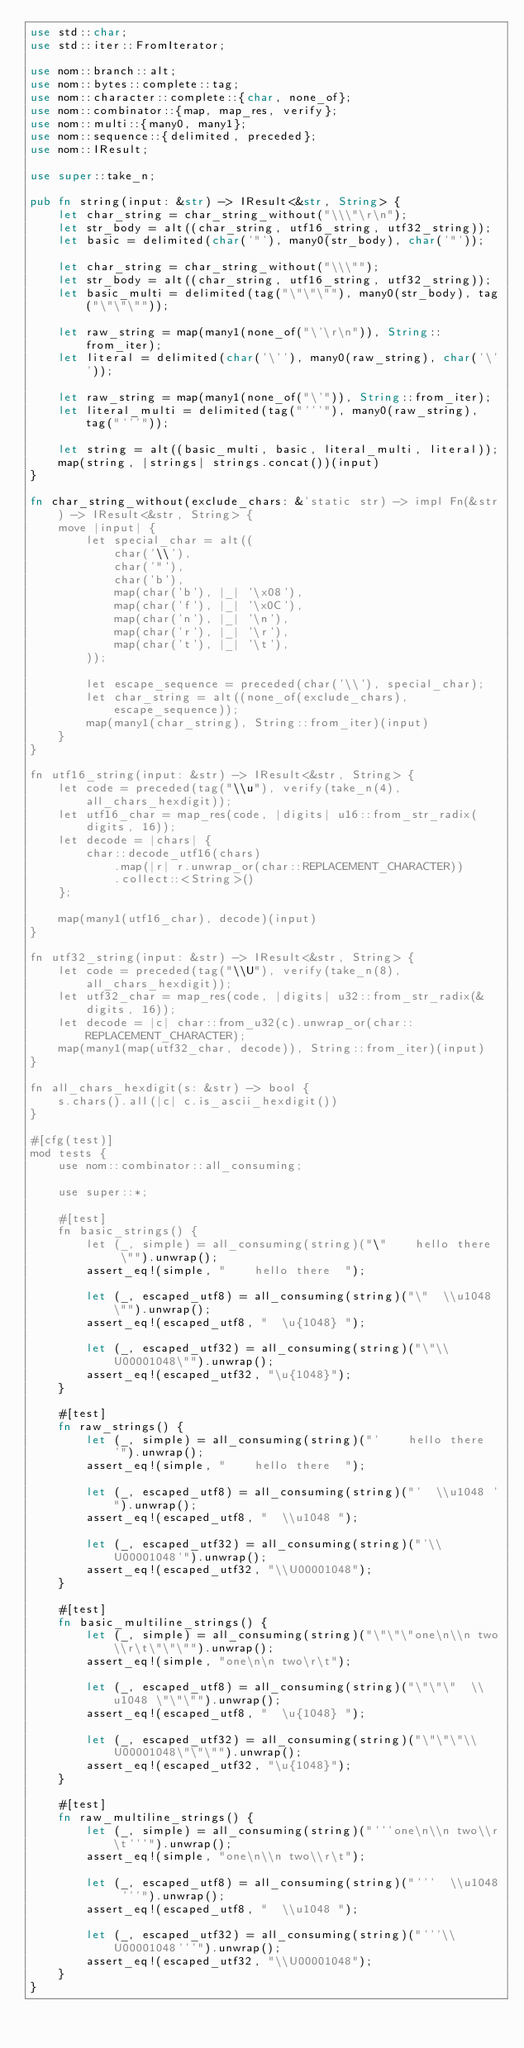Convert code to text. <code><loc_0><loc_0><loc_500><loc_500><_Rust_>use std::char;
use std::iter::FromIterator;

use nom::branch::alt;
use nom::bytes::complete::tag;
use nom::character::complete::{char, none_of};
use nom::combinator::{map, map_res, verify};
use nom::multi::{many0, many1};
use nom::sequence::{delimited, preceded};
use nom::IResult;

use super::take_n;

pub fn string(input: &str) -> IResult<&str, String> {
    let char_string = char_string_without("\\\"\r\n");
    let str_body = alt((char_string, utf16_string, utf32_string));
    let basic = delimited(char('"'), many0(str_body), char('"'));

    let char_string = char_string_without("\\\"");
    let str_body = alt((char_string, utf16_string, utf32_string));
    let basic_multi = delimited(tag("\"\"\""), many0(str_body), tag("\"\"\""));

    let raw_string = map(many1(none_of("\'\r\n")), String::from_iter);
    let literal = delimited(char('\''), many0(raw_string), char('\''));

    let raw_string = map(many1(none_of("\'")), String::from_iter);
    let literal_multi = delimited(tag("'''"), many0(raw_string), tag("'''"));

    let string = alt((basic_multi, basic, literal_multi, literal));
    map(string, |strings| strings.concat())(input)
}

fn char_string_without(exclude_chars: &'static str) -> impl Fn(&str) -> IResult<&str, String> {
    move |input| {
        let special_char = alt((
            char('\\'),
            char('"'),
            char('b'),
            map(char('b'), |_| '\x08'),
            map(char('f'), |_| '\x0C'),
            map(char('n'), |_| '\n'),
            map(char('r'), |_| '\r'),
            map(char('t'), |_| '\t'),
        ));

        let escape_sequence = preceded(char('\\'), special_char);
        let char_string = alt((none_of(exclude_chars), escape_sequence));
        map(many1(char_string), String::from_iter)(input)
    }
}

fn utf16_string(input: &str) -> IResult<&str, String> {
    let code = preceded(tag("\\u"), verify(take_n(4), all_chars_hexdigit));
    let utf16_char = map_res(code, |digits| u16::from_str_radix(digits, 16));
    let decode = |chars| {
        char::decode_utf16(chars)
            .map(|r| r.unwrap_or(char::REPLACEMENT_CHARACTER))
            .collect::<String>()
    };

    map(many1(utf16_char), decode)(input)
}

fn utf32_string(input: &str) -> IResult<&str, String> {
    let code = preceded(tag("\\U"), verify(take_n(8), all_chars_hexdigit));
    let utf32_char = map_res(code, |digits| u32::from_str_radix(&digits, 16));
    let decode = |c| char::from_u32(c).unwrap_or(char::REPLACEMENT_CHARACTER);
    map(many1(map(utf32_char, decode)), String::from_iter)(input)
}

fn all_chars_hexdigit(s: &str) -> bool {
    s.chars().all(|c| c.is_ascii_hexdigit())
}

#[cfg(test)]
mod tests {
    use nom::combinator::all_consuming;

    use super::*;

    #[test]
    fn basic_strings() {
        let (_, simple) = all_consuming(string)("\"    hello there  \"").unwrap();
        assert_eq!(simple, "    hello there  ");

        let (_, escaped_utf8) = all_consuming(string)("\"  \\u1048 \"").unwrap();
        assert_eq!(escaped_utf8, "  \u{1048} ");

        let (_, escaped_utf32) = all_consuming(string)("\"\\U00001048\"").unwrap();
        assert_eq!(escaped_utf32, "\u{1048}");
    }

    #[test]
    fn raw_strings() {
        let (_, simple) = all_consuming(string)("'    hello there  '").unwrap();
        assert_eq!(simple, "    hello there  ");

        let (_, escaped_utf8) = all_consuming(string)("'  \\u1048 '").unwrap();
        assert_eq!(escaped_utf8, "  \\u1048 ");

        let (_, escaped_utf32) = all_consuming(string)("'\\U00001048'").unwrap();
        assert_eq!(escaped_utf32, "\\U00001048");
    }

    #[test]
    fn basic_multiline_strings() {
        let (_, simple) = all_consuming(string)("\"\"\"one\n\\n two\\r\t\"\"\"").unwrap();
        assert_eq!(simple, "one\n\n two\r\t");

        let (_, escaped_utf8) = all_consuming(string)("\"\"\"  \\u1048 \"\"\"").unwrap();
        assert_eq!(escaped_utf8, "  \u{1048} ");

        let (_, escaped_utf32) = all_consuming(string)("\"\"\"\\U00001048\"\"\"").unwrap();
        assert_eq!(escaped_utf32, "\u{1048}");
    }

    #[test]
    fn raw_multiline_strings() {
        let (_, simple) = all_consuming(string)("'''one\n\\n two\\r\t'''").unwrap();
        assert_eq!(simple, "one\n\\n two\\r\t");

        let (_, escaped_utf8) = all_consuming(string)("'''  \\u1048 '''").unwrap();
        assert_eq!(escaped_utf8, "  \\u1048 ");

        let (_, escaped_utf32) = all_consuming(string)("'''\\U00001048'''").unwrap();
        assert_eq!(escaped_utf32, "\\U00001048");
    }
}
</code> 